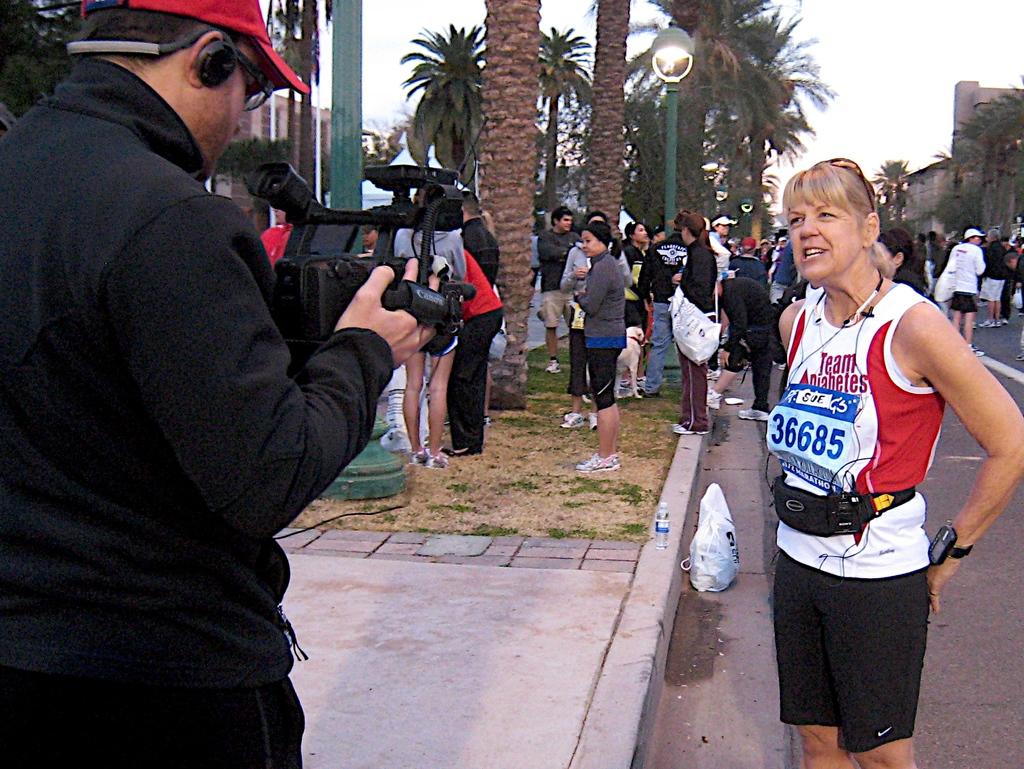What number is on the woman sign?
Your answer should be very brief. 36685. 